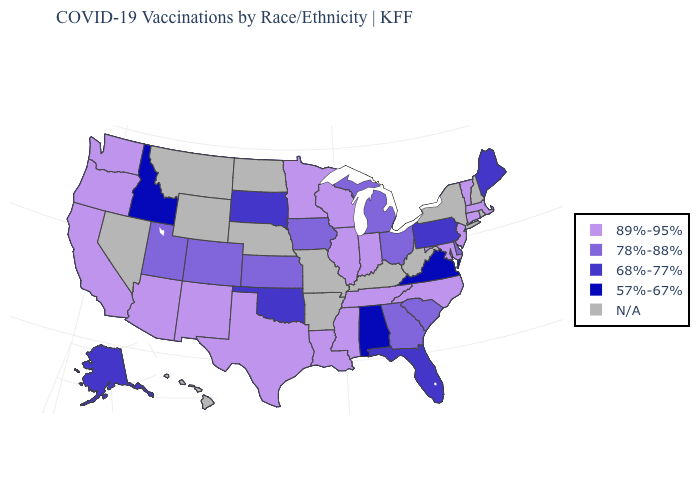Among the states that border North Carolina , which have the highest value?
Keep it brief. Tennessee. What is the value of Hawaii?
Short answer required. N/A. What is the lowest value in the USA?
Concise answer only. 57%-67%. Among the states that border Florida , which have the lowest value?
Concise answer only. Alabama. Does Ohio have the highest value in the USA?
Concise answer only. No. Does the map have missing data?
Quick response, please. Yes. What is the value of Utah?
Concise answer only. 78%-88%. Name the states that have a value in the range 89%-95%?
Short answer required. Arizona, California, Connecticut, Illinois, Indiana, Louisiana, Maryland, Massachusetts, Minnesota, Mississippi, New Jersey, New Mexico, North Carolina, Oregon, Tennessee, Texas, Vermont, Washington, Wisconsin. Name the states that have a value in the range 78%-88%?
Keep it brief. Colorado, Delaware, Georgia, Iowa, Kansas, Michigan, Ohio, South Carolina, Utah. What is the value of Kentucky?
Give a very brief answer. N/A. Does Kansas have the lowest value in the MidWest?
Keep it brief. No. Does Kansas have the highest value in the MidWest?
Write a very short answer. No. Name the states that have a value in the range 57%-67%?
Keep it brief. Alabama, Idaho, Virginia. Among the states that border Nebraska , does South Dakota have the highest value?
Concise answer only. No. 